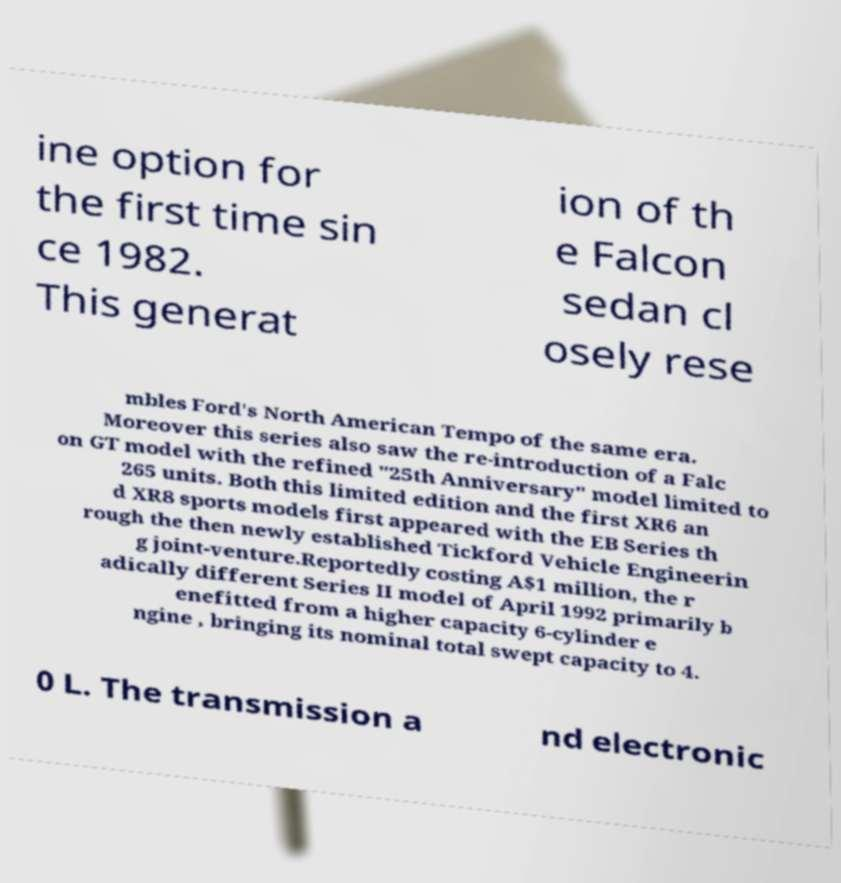Could you assist in decoding the text presented in this image and type it out clearly? ine option for the first time sin ce 1982. This generat ion of th e Falcon sedan cl osely rese mbles Ford's North American Tempo of the same era. Moreover this series also saw the re-introduction of a Falc on GT model with the refined "25th Anniversary" model limited to 265 units. Both this limited edition and the first XR6 an d XR8 sports models first appeared with the EB Series th rough the then newly established Tickford Vehicle Engineerin g joint-venture.Reportedly costing A$1 million, the r adically different Series II model of April 1992 primarily b enefitted from a higher capacity 6-cylinder e ngine , bringing its nominal total swept capacity to 4. 0 L. The transmission a nd electronic 